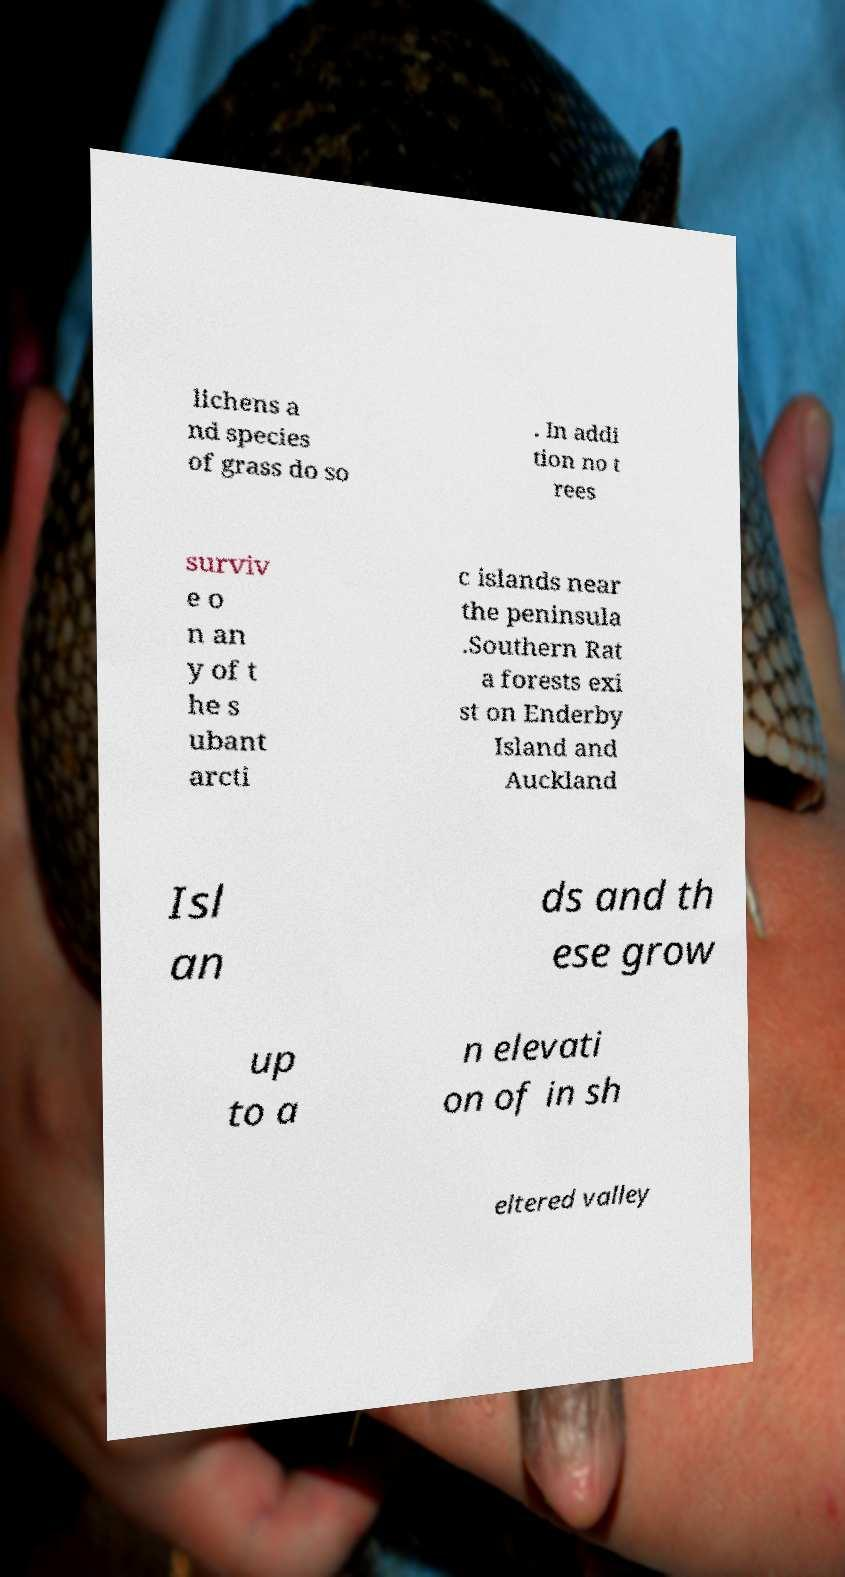For documentation purposes, I need the text within this image transcribed. Could you provide that? lichens a nd species of grass do so . In addi tion no t rees surviv e o n an y of t he s ubant arcti c islands near the peninsula .Southern Rat a forests exi st on Enderby Island and Auckland Isl an ds and th ese grow up to a n elevati on of in sh eltered valley 